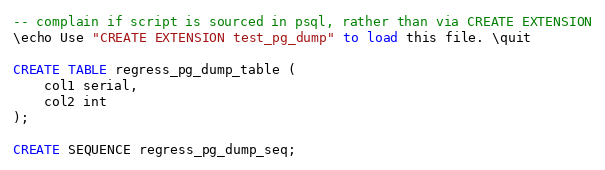Convert code to text. <code><loc_0><loc_0><loc_500><loc_500><_SQL_>-- complain if script is sourced in psql, rather than via CREATE EXTENSION
\echo Use "CREATE EXTENSION test_pg_dump" to load this file. \quit

CREATE TABLE regress_pg_dump_table (
	col1 serial,
	col2 int
);

CREATE SEQUENCE regress_pg_dump_seq;
</code> 